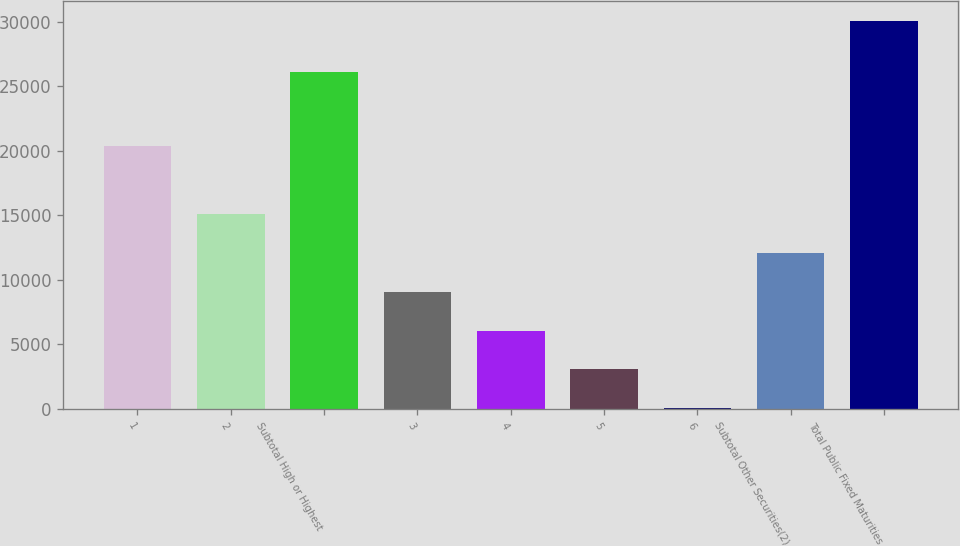<chart> <loc_0><loc_0><loc_500><loc_500><bar_chart><fcel>1<fcel>2<fcel>Subtotal High or Highest<fcel>3<fcel>4<fcel>5<fcel>6<fcel>Subtotal Other Securities(2)<fcel>Total Public Fixed Maturities<nl><fcel>20374<fcel>15087.5<fcel>26106<fcel>9083.3<fcel>6081.2<fcel>3079.1<fcel>77<fcel>12085.4<fcel>30098<nl></chart> 